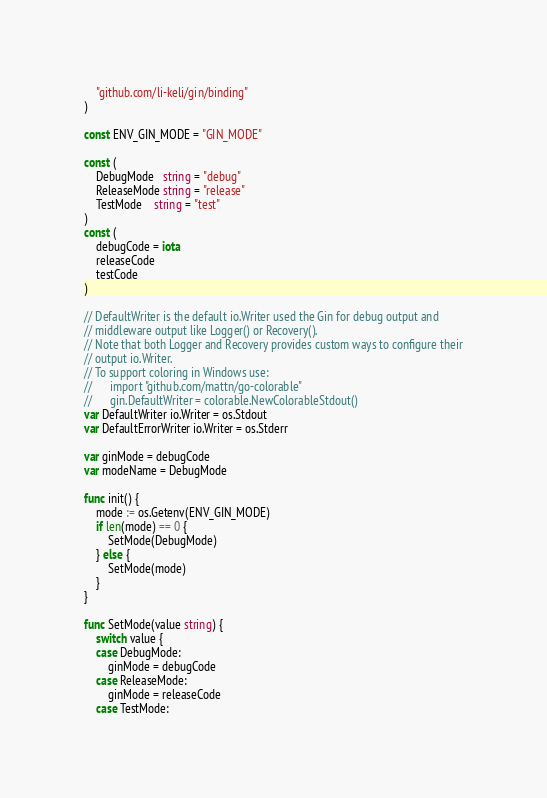Convert code to text. <code><loc_0><loc_0><loc_500><loc_500><_Go_>
	"github.com/li-keli/gin/binding"
)

const ENV_GIN_MODE = "GIN_MODE"

const (
	DebugMode   string = "debug"
	ReleaseMode string = "release"
	TestMode    string = "test"
)
const (
	debugCode = iota
	releaseCode
	testCode
)

// DefaultWriter is the default io.Writer used the Gin for debug output and
// middleware output like Logger() or Recovery().
// Note that both Logger and Recovery provides custom ways to configure their
// output io.Writer.
// To support coloring in Windows use:
// 		import "github.com/mattn/go-colorable"
// 		gin.DefaultWriter = colorable.NewColorableStdout()
var DefaultWriter io.Writer = os.Stdout
var DefaultErrorWriter io.Writer = os.Stderr

var ginMode = debugCode
var modeName = DebugMode

func init() {
	mode := os.Getenv(ENV_GIN_MODE)
	if len(mode) == 0 {
		SetMode(DebugMode)
	} else {
		SetMode(mode)
	}
}

func SetMode(value string) {
	switch value {
	case DebugMode:
		ginMode = debugCode
	case ReleaseMode:
		ginMode = releaseCode
	case TestMode:</code> 